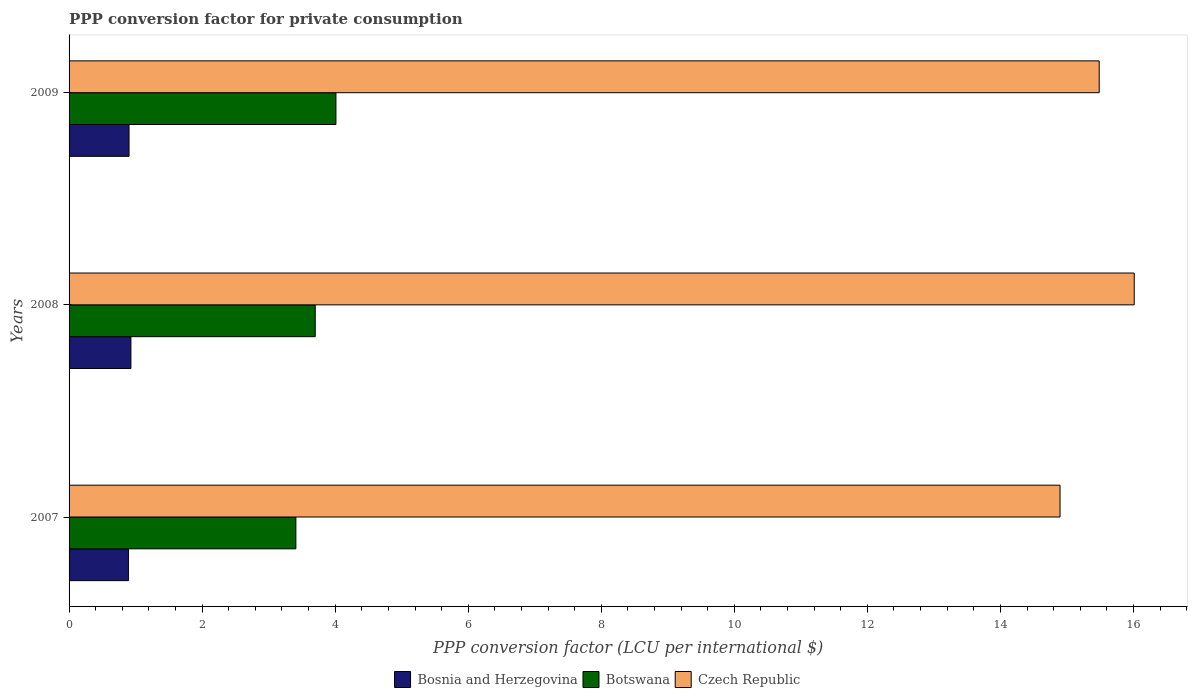Are the number of bars per tick equal to the number of legend labels?
Your answer should be very brief. Yes. Are the number of bars on each tick of the Y-axis equal?
Make the answer very short. Yes. How many bars are there on the 3rd tick from the bottom?
Ensure brevity in your answer.  3. What is the PPP conversion factor for private consumption in Bosnia and Herzegovina in 2007?
Give a very brief answer. 0.89. Across all years, what is the maximum PPP conversion factor for private consumption in Bosnia and Herzegovina?
Ensure brevity in your answer.  0.93. Across all years, what is the minimum PPP conversion factor for private consumption in Bosnia and Herzegovina?
Give a very brief answer. 0.89. In which year was the PPP conversion factor for private consumption in Bosnia and Herzegovina maximum?
Make the answer very short. 2008. In which year was the PPP conversion factor for private consumption in Botswana minimum?
Make the answer very short. 2007. What is the total PPP conversion factor for private consumption in Bosnia and Herzegovina in the graph?
Your response must be concise. 2.72. What is the difference between the PPP conversion factor for private consumption in Czech Republic in 2008 and that in 2009?
Offer a very short reply. 0.53. What is the difference between the PPP conversion factor for private consumption in Botswana in 2009 and the PPP conversion factor for private consumption in Bosnia and Herzegovina in 2007?
Offer a terse response. 3.12. What is the average PPP conversion factor for private consumption in Bosnia and Herzegovina per year?
Keep it short and to the point. 0.91. In the year 2008, what is the difference between the PPP conversion factor for private consumption in Czech Republic and PPP conversion factor for private consumption in Botswana?
Your answer should be very brief. 12.31. In how many years, is the PPP conversion factor for private consumption in Bosnia and Herzegovina greater than 10.4 LCU?
Give a very brief answer. 0. What is the ratio of the PPP conversion factor for private consumption in Bosnia and Herzegovina in 2007 to that in 2009?
Your response must be concise. 0.99. Is the PPP conversion factor for private consumption in Czech Republic in 2007 less than that in 2008?
Make the answer very short. Yes. What is the difference between the highest and the second highest PPP conversion factor for private consumption in Czech Republic?
Your answer should be very brief. 0.53. What is the difference between the highest and the lowest PPP conversion factor for private consumption in Bosnia and Herzegovina?
Offer a terse response. 0.04. What does the 1st bar from the top in 2008 represents?
Offer a terse response. Czech Republic. What does the 2nd bar from the bottom in 2009 represents?
Provide a short and direct response. Botswana. Is it the case that in every year, the sum of the PPP conversion factor for private consumption in Czech Republic and PPP conversion factor for private consumption in Botswana is greater than the PPP conversion factor for private consumption in Bosnia and Herzegovina?
Provide a short and direct response. Yes. Are all the bars in the graph horizontal?
Provide a short and direct response. Yes. How many years are there in the graph?
Your answer should be compact. 3. What is the difference between two consecutive major ticks on the X-axis?
Ensure brevity in your answer.  2. Where does the legend appear in the graph?
Your response must be concise. Bottom center. How many legend labels are there?
Make the answer very short. 3. How are the legend labels stacked?
Keep it short and to the point. Horizontal. What is the title of the graph?
Offer a terse response. PPP conversion factor for private consumption. What is the label or title of the X-axis?
Keep it short and to the point. PPP conversion factor (LCU per international $). What is the PPP conversion factor (LCU per international $) in Bosnia and Herzegovina in 2007?
Give a very brief answer. 0.89. What is the PPP conversion factor (LCU per international $) in Botswana in 2007?
Ensure brevity in your answer.  3.41. What is the PPP conversion factor (LCU per international $) in Czech Republic in 2007?
Keep it short and to the point. 14.9. What is the PPP conversion factor (LCU per international $) in Bosnia and Herzegovina in 2008?
Provide a short and direct response. 0.93. What is the PPP conversion factor (LCU per international $) in Botswana in 2008?
Your answer should be compact. 3.7. What is the PPP conversion factor (LCU per international $) of Czech Republic in 2008?
Make the answer very short. 16.01. What is the PPP conversion factor (LCU per international $) in Bosnia and Herzegovina in 2009?
Your response must be concise. 0.9. What is the PPP conversion factor (LCU per international $) in Botswana in 2009?
Your answer should be compact. 4.01. What is the PPP conversion factor (LCU per international $) in Czech Republic in 2009?
Provide a succinct answer. 15.48. Across all years, what is the maximum PPP conversion factor (LCU per international $) in Bosnia and Herzegovina?
Ensure brevity in your answer.  0.93. Across all years, what is the maximum PPP conversion factor (LCU per international $) in Botswana?
Offer a very short reply. 4.01. Across all years, what is the maximum PPP conversion factor (LCU per international $) of Czech Republic?
Your response must be concise. 16.01. Across all years, what is the minimum PPP conversion factor (LCU per international $) of Bosnia and Herzegovina?
Your answer should be compact. 0.89. Across all years, what is the minimum PPP conversion factor (LCU per international $) in Botswana?
Your answer should be compact. 3.41. Across all years, what is the minimum PPP conversion factor (LCU per international $) of Czech Republic?
Provide a short and direct response. 14.9. What is the total PPP conversion factor (LCU per international $) of Bosnia and Herzegovina in the graph?
Provide a short and direct response. 2.72. What is the total PPP conversion factor (LCU per international $) of Botswana in the graph?
Your answer should be very brief. 11.12. What is the total PPP conversion factor (LCU per international $) in Czech Republic in the graph?
Your response must be concise. 46.39. What is the difference between the PPP conversion factor (LCU per international $) of Bosnia and Herzegovina in 2007 and that in 2008?
Make the answer very short. -0.04. What is the difference between the PPP conversion factor (LCU per international $) in Botswana in 2007 and that in 2008?
Offer a very short reply. -0.29. What is the difference between the PPP conversion factor (LCU per international $) in Czech Republic in 2007 and that in 2008?
Provide a short and direct response. -1.12. What is the difference between the PPP conversion factor (LCU per international $) in Bosnia and Herzegovina in 2007 and that in 2009?
Provide a short and direct response. -0.01. What is the difference between the PPP conversion factor (LCU per international $) in Botswana in 2007 and that in 2009?
Offer a very short reply. -0.6. What is the difference between the PPP conversion factor (LCU per international $) of Czech Republic in 2007 and that in 2009?
Keep it short and to the point. -0.59. What is the difference between the PPP conversion factor (LCU per international $) in Bosnia and Herzegovina in 2008 and that in 2009?
Provide a succinct answer. 0.03. What is the difference between the PPP conversion factor (LCU per international $) in Botswana in 2008 and that in 2009?
Provide a short and direct response. -0.31. What is the difference between the PPP conversion factor (LCU per international $) of Czech Republic in 2008 and that in 2009?
Your answer should be compact. 0.53. What is the difference between the PPP conversion factor (LCU per international $) in Bosnia and Herzegovina in 2007 and the PPP conversion factor (LCU per international $) in Botswana in 2008?
Your answer should be very brief. -2.81. What is the difference between the PPP conversion factor (LCU per international $) of Bosnia and Herzegovina in 2007 and the PPP conversion factor (LCU per international $) of Czech Republic in 2008?
Offer a terse response. -15.12. What is the difference between the PPP conversion factor (LCU per international $) in Botswana in 2007 and the PPP conversion factor (LCU per international $) in Czech Republic in 2008?
Make the answer very short. -12.6. What is the difference between the PPP conversion factor (LCU per international $) in Bosnia and Herzegovina in 2007 and the PPP conversion factor (LCU per international $) in Botswana in 2009?
Give a very brief answer. -3.12. What is the difference between the PPP conversion factor (LCU per international $) in Bosnia and Herzegovina in 2007 and the PPP conversion factor (LCU per international $) in Czech Republic in 2009?
Give a very brief answer. -14.59. What is the difference between the PPP conversion factor (LCU per international $) of Botswana in 2007 and the PPP conversion factor (LCU per international $) of Czech Republic in 2009?
Give a very brief answer. -12.08. What is the difference between the PPP conversion factor (LCU per international $) in Bosnia and Herzegovina in 2008 and the PPP conversion factor (LCU per international $) in Botswana in 2009?
Give a very brief answer. -3.08. What is the difference between the PPP conversion factor (LCU per international $) in Bosnia and Herzegovina in 2008 and the PPP conversion factor (LCU per international $) in Czech Republic in 2009?
Ensure brevity in your answer.  -14.55. What is the difference between the PPP conversion factor (LCU per international $) of Botswana in 2008 and the PPP conversion factor (LCU per international $) of Czech Republic in 2009?
Offer a terse response. -11.78. What is the average PPP conversion factor (LCU per international $) in Bosnia and Herzegovina per year?
Give a very brief answer. 0.91. What is the average PPP conversion factor (LCU per international $) of Botswana per year?
Make the answer very short. 3.71. What is the average PPP conversion factor (LCU per international $) in Czech Republic per year?
Ensure brevity in your answer.  15.46. In the year 2007, what is the difference between the PPP conversion factor (LCU per international $) of Bosnia and Herzegovina and PPP conversion factor (LCU per international $) of Botswana?
Your answer should be very brief. -2.52. In the year 2007, what is the difference between the PPP conversion factor (LCU per international $) in Bosnia and Herzegovina and PPP conversion factor (LCU per international $) in Czech Republic?
Offer a terse response. -14. In the year 2007, what is the difference between the PPP conversion factor (LCU per international $) in Botswana and PPP conversion factor (LCU per international $) in Czech Republic?
Offer a terse response. -11.49. In the year 2008, what is the difference between the PPP conversion factor (LCU per international $) of Bosnia and Herzegovina and PPP conversion factor (LCU per international $) of Botswana?
Offer a very short reply. -2.77. In the year 2008, what is the difference between the PPP conversion factor (LCU per international $) in Bosnia and Herzegovina and PPP conversion factor (LCU per international $) in Czech Republic?
Your answer should be compact. -15.08. In the year 2008, what is the difference between the PPP conversion factor (LCU per international $) of Botswana and PPP conversion factor (LCU per international $) of Czech Republic?
Make the answer very short. -12.31. In the year 2009, what is the difference between the PPP conversion factor (LCU per international $) in Bosnia and Herzegovina and PPP conversion factor (LCU per international $) in Botswana?
Your answer should be very brief. -3.11. In the year 2009, what is the difference between the PPP conversion factor (LCU per international $) of Bosnia and Herzegovina and PPP conversion factor (LCU per international $) of Czech Republic?
Make the answer very short. -14.58. In the year 2009, what is the difference between the PPP conversion factor (LCU per international $) in Botswana and PPP conversion factor (LCU per international $) in Czech Republic?
Provide a short and direct response. -11.47. What is the ratio of the PPP conversion factor (LCU per international $) in Bosnia and Herzegovina in 2007 to that in 2008?
Keep it short and to the point. 0.96. What is the ratio of the PPP conversion factor (LCU per international $) of Botswana in 2007 to that in 2008?
Provide a short and direct response. 0.92. What is the ratio of the PPP conversion factor (LCU per international $) of Czech Republic in 2007 to that in 2008?
Give a very brief answer. 0.93. What is the ratio of the PPP conversion factor (LCU per international $) of Botswana in 2007 to that in 2009?
Offer a terse response. 0.85. What is the ratio of the PPP conversion factor (LCU per international $) in Bosnia and Herzegovina in 2008 to that in 2009?
Keep it short and to the point. 1.03. What is the ratio of the PPP conversion factor (LCU per international $) in Botswana in 2008 to that in 2009?
Give a very brief answer. 0.92. What is the ratio of the PPP conversion factor (LCU per international $) of Czech Republic in 2008 to that in 2009?
Give a very brief answer. 1.03. What is the difference between the highest and the second highest PPP conversion factor (LCU per international $) in Bosnia and Herzegovina?
Your answer should be compact. 0.03. What is the difference between the highest and the second highest PPP conversion factor (LCU per international $) in Botswana?
Offer a terse response. 0.31. What is the difference between the highest and the second highest PPP conversion factor (LCU per international $) of Czech Republic?
Offer a very short reply. 0.53. What is the difference between the highest and the lowest PPP conversion factor (LCU per international $) of Bosnia and Herzegovina?
Keep it short and to the point. 0.04. What is the difference between the highest and the lowest PPP conversion factor (LCU per international $) of Botswana?
Make the answer very short. 0.6. What is the difference between the highest and the lowest PPP conversion factor (LCU per international $) of Czech Republic?
Keep it short and to the point. 1.12. 